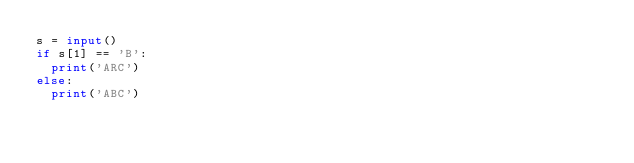Convert code to text. <code><loc_0><loc_0><loc_500><loc_500><_Python_>s = input()
if s[1] == 'B':
  print('ARC')
else:
  print('ABC')</code> 